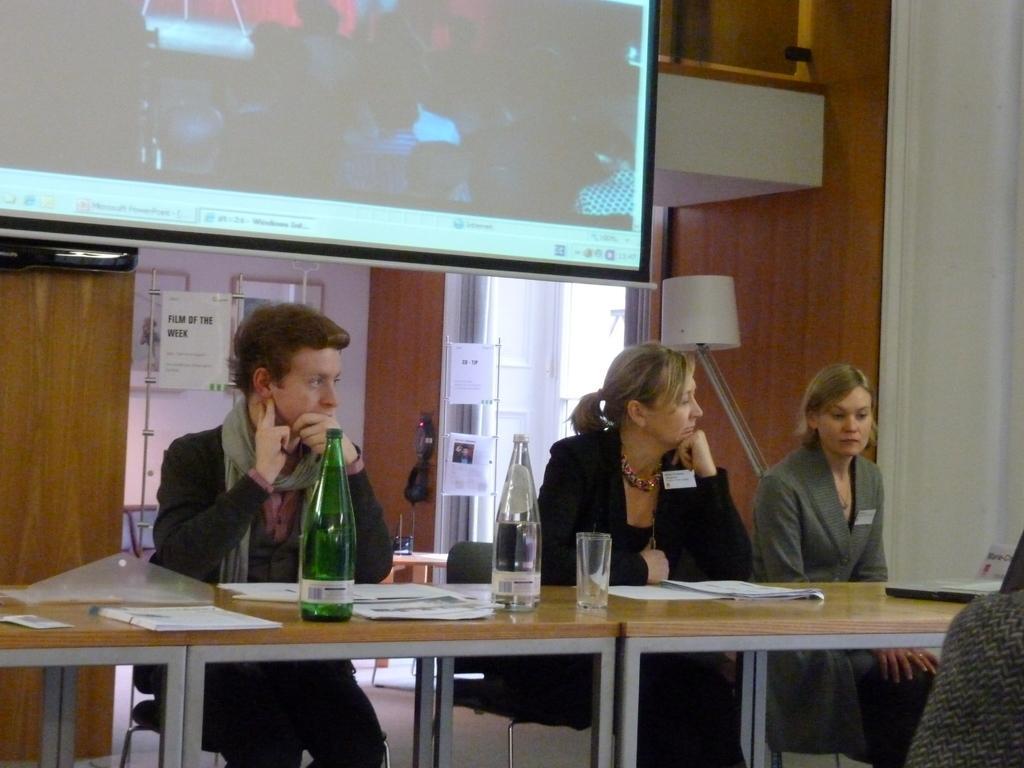Can you describe this image briefly? In the picture there is a table and in front of the table there are total people sitting,on the table there are some papers,bottles and glasses in the background there is a projector screen and something is being projected on the screen,below that there is a door,to the right side there is a lamp. 